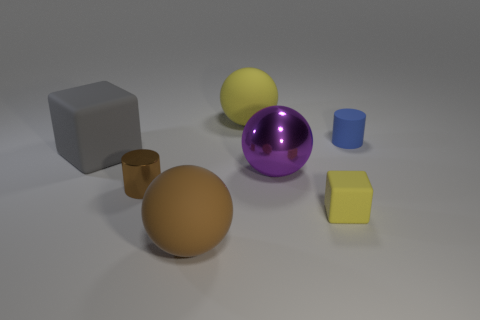Is the number of brown metal things behind the large yellow thing the same as the number of big green spheres?
Give a very brief answer. Yes. There is a brown metal thing that is the same size as the rubber cylinder; what shape is it?
Give a very brief answer. Cylinder. What material is the tiny brown object?
Make the answer very short. Metal. There is a thing that is both on the left side of the tiny yellow matte object and behind the big gray cube; what color is it?
Your response must be concise. Yellow. Is the number of big gray rubber things right of the big matte block the same as the number of cubes in front of the tiny metallic object?
Keep it short and to the point. No. What is the color of the tiny object that is made of the same material as the tiny yellow block?
Provide a short and direct response. Blue. Do the tiny metal cylinder and the big object in front of the metallic cylinder have the same color?
Offer a very short reply. Yes. Are there any small brown metal things that are in front of the yellow matte thing on the right side of the metal thing on the right side of the shiny cylinder?
Provide a succinct answer. No. What shape is the large yellow object that is the same material as the big cube?
Offer a terse response. Sphere. What shape is the large gray matte thing?
Keep it short and to the point. Cube. 